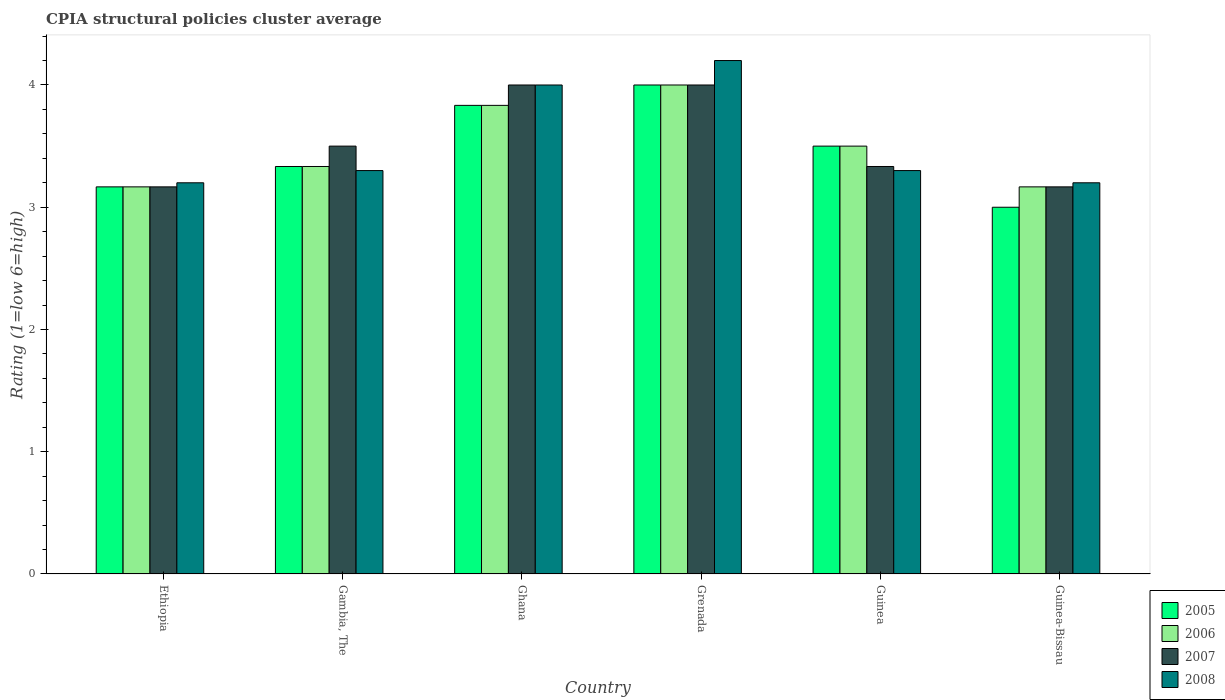How many different coloured bars are there?
Make the answer very short. 4. Are the number of bars per tick equal to the number of legend labels?
Your answer should be very brief. Yes. Are the number of bars on each tick of the X-axis equal?
Keep it short and to the point. Yes. How many bars are there on the 6th tick from the left?
Give a very brief answer. 4. How many bars are there on the 6th tick from the right?
Ensure brevity in your answer.  4. What is the label of the 6th group of bars from the left?
Provide a succinct answer. Guinea-Bissau. In how many cases, is the number of bars for a given country not equal to the number of legend labels?
Your answer should be very brief. 0. Across all countries, what is the maximum CPIA rating in 2005?
Keep it short and to the point. 4. In which country was the CPIA rating in 2008 maximum?
Keep it short and to the point. Grenada. In which country was the CPIA rating in 2007 minimum?
Your response must be concise. Ethiopia. What is the total CPIA rating in 2008 in the graph?
Your answer should be very brief. 21.2. What is the difference between the CPIA rating in 2005 in Grenada and that in Guinea-Bissau?
Provide a succinct answer. 1. What is the difference between the CPIA rating in 2007 in Ethiopia and the CPIA rating in 2005 in Grenada?
Ensure brevity in your answer.  -0.83. What is the average CPIA rating in 2008 per country?
Provide a short and direct response. 3.53. What is the difference between the CPIA rating of/in 2008 and CPIA rating of/in 2007 in Guinea-Bissau?
Ensure brevity in your answer.  0.03. In how many countries, is the CPIA rating in 2005 greater than 4?
Give a very brief answer. 0. What is the ratio of the CPIA rating in 2005 in Ethiopia to that in Guinea?
Provide a short and direct response. 0.9. Is the CPIA rating in 2008 in Ghana less than that in Guinea-Bissau?
Give a very brief answer. No. Is the difference between the CPIA rating in 2008 in Gambia, The and Ghana greater than the difference between the CPIA rating in 2007 in Gambia, The and Ghana?
Your answer should be compact. No. What is the difference between the highest and the second highest CPIA rating in 2005?
Provide a short and direct response. -0.33. What is the difference between the highest and the lowest CPIA rating in 2006?
Provide a succinct answer. 0.83. In how many countries, is the CPIA rating in 2007 greater than the average CPIA rating in 2007 taken over all countries?
Offer a terse response. 2. Is it the case that in every country, the sum of the CPIA rating in 2006 and CPIA rating in 2005 is greater than the sum of CPIA rating in 2008 and CPIA rating in 2007?
Give a very brief answer. No. What does the 3rd bar from the left in Guinea-Bissau represents?
Make the answer very short. 2007. What does the 3rd bar from the right in Ethiopia represents?
Offer a very short reply. 2006. How many bars are there?
Give a very brief answer. 24. What is the difference between two consecutive major ticks on the Y-axis?
Offer a terse response. 1. Are the values on the major ticks of Y-axis written in scientific E-notation?
Your answer should be very brief. No. How many legend labels are there?
Provide a short and direct response. 4. How are the legend labels stacked?
Provide a succinct answer. Vertical. What is the title of the graph?
Keep it short and to the point. CPIA structural policies cluster average. What is the label or title of the X-axis?
Ensure brevity in your answer.  Country. What is the Rating (1=low 6=high) in 2005 in Ethiopia?
Your response must be concise. 3.17. What is the Rating (1=low 6=high) in 2006 in Ethiopia?
Ensure brevity in your answer.  3.17. What is the Rating (1=low 6=high) of 2007 in Ethiopia?
Your answer should be very brief. 3.17. What is the Rating (1=low 6=high) in 2005 in Gambia, The?
Offer a terse response. 3.33. What is the Rating (1=low 6=high) in 2006 in Gambia, The?
Provide a succinct answer. 3.33. What is the Rating (1=low 6=high) of 2008 in Gambia, The?
Your response must be concise. 3.3. What is the Rating (1=low 6=high) of 2005 in Ghana?
Offer a very short reply. 3.83. What is the Rating (1=low 6=high) of 2006 in Ghana?
Ensure brevity in your answer.  3.83. What is the Rating (1=low 6=high) of 2007 in Ghana?
Offer a very short reply. 4. What is the Rating (1=low 6=high) in 2008 in Ghana?
Give a very brief answer. 4. What is the Rating (1=low 6=high) of 2005 in Grenada?
Provide a succinct answer. 4. What is the Rating (1=low 6=high) of 2006 in Grenada?
Keep it short and to the point. 4. What is the Rating (1=low 6=high) in 2007 in Grenada?
Ensure brevity in your answer.  4. What is the Rating (1=low 6=high) of 2007 in Guinea?
Keep it short and to the point. 3.33. What is the Rating (1=low 6=high) in 2008 in Guinea?
Provide a succinct answer. 3.3. What is the Rating (1=low 6=high) of 2006 in Guinea-Bissau?
Make the answer very short. 3.17. What is the Rating (1=low 6=high) of 2007 in Guinea-Bissau?
Keep it short and to the point. 3.17. Across all countries, what is the maximum Rating (1=low 6=high) of 2008?
Offer a terse response. 4.2. Across all countries, what is the minimum Rating (1=low 6=high) in 2005?
Your response must be concise. 3. Across all countries, what is the minimum Rating (1=low 6=high) of 2006?
Your answer should be compact. 3.17. Across all countries, what is the minimum Rating (1=low 6=high) in 2007?
Your answer should be compact. 3.17. What is the total Rating (1=low 6=high) in 2005 in the graph?
Your answer should be compact. 20.83. What is the total Rating (1=low 6=high) in 2007 in the graph?
Offer a very short reply. 21.17. What is the total Rating (1=low 6=high) in 2008 in the graph?
Ensure brevity in your answer.  21.2. What is the difference between the Rating (1=low 6=high) in 2005 in Ethiopia and that in Gambia, The?
Ensure brevity in your answer.  -0.17. What is the difference between the Rating (1=low 6=high) of 2006 in Ethiopia and that in Gambia, The?
Your answer should be compact. -0.17. What is the difference between the Rating (1=low 6=high) of 2008 in Ethiopia and that in Gambia, The?
Give a very brief answer. -0.1. What is the difference between the Rating (1=low 6=high) of 2005 in Ethiopia and that in Ghana?
Your answer should be very brief. -0.67. What is the difference between the Rating (1=low 6=high) of 2007 in Ethiopia and that in Ghana?
Make the answer very short. -0.83. What is the difference between the Rating (1=low 6=high) of 2005 in Ethiopia and that in Guinea-Bissau?
Your response must be concise. 0.17. What is the difference between the Rating (1=low 6=high) in 2008 in Ethiopia and that in Guinea-Bissau?
Offer a very short reply. 0. What is the difference between the Rating (1=low 6=high) in 2006 in Gambia, The and that in Ghana?
Your response must be concise. -0.5. What is the difference between the Rating (1=low 6=high) of 2008 in Gambia, The and that in Ghana?
Give a very brief answer. -0.7. What is the difference between the Rating (1=low 6=high) of 2005 in Gambia, The and that in Grenada?
Offer a terse response. -0.67. What is the difference between the Rating (1=low 6=high) in 2007 in Gambia, The and that in Grenada?
Provide a succinct answer. -0.5. What is the difference between the Rating (1=low 6=high) of 2005 in Gambia, The and that in Guinea?
Your answer should be compact. -0.17. What is the difference between the Rating (1=low 6=high) in 2007 in Gambia, The and that in Guinea?
Keep it short and to the point. 0.17. What is the difference between the Rating (1=low 6=high) in 2005 in Gambia, The and that in Guinea-Bissau?
Your answer should be very brief. 0.33. What is the difference between the Rating (1=low 6=high) in 2006 in Gambia, The and that in Guinea-Bissau?
Your answer should be compact. 0.17. What is the difference between the Rating (1=low 6=high) in 2008 in Gambia, The and that in Guinea-Bissau?
Offer a very short reply. 0.1. What is the difference between the Rating (1=low 6=high) in 2005 in Ghana and that in Grenada?
Provide a short and direct response. -0.17. What is the difference between the Rating (1=low 6=high) of 2008 in Ghana and that in Grenada?
Your answer should be compact. -0.2. What is the difference between the Rating (1=low 6=high) of 2007 in Ghana and that in Guinea?
Provide a short and direct response. 0.67. What is the difference between the Rating (1=low 6=high) of 2008 in Ghana and that in Guinea?
Offer a very short reply. 0.7. What is the difference between the Rating (1=low 6=high) in 2006 in Ghana and that in Guinea-Bissau?
Keep it short and to the point. 0.67. What is the difference between the Rating (1=low 6=high) in 2005 in Grenada and that in Guinea?
Provide a succinct answer. 0.5. What is the difference between the Rating (1=low 6=high) of 2007 in Grenada and that in Guinea?
Ensure brevity in your answer.  0.67. What is the difference between the Rating (1=low 6=high) of 2008 in Grenada and that in Guinea?
Give a very brief answer. 0.9. What is the difference between the Rating (1=low 6=high) in 2005 in Grenada and that in Guinea-Bissau?
Make the answer very short. 1. What is the difference between the Rating (1=low 6=high) in 2007 in Grenada and that in Guinea-Bissau?
Give a very brief answer. 0.83. What is the difference between the Rating (1=low 6=high) in 2008 in Grenada and that in Guinea-Bissau?
Offer a terse response. 1. What is the difference between the Rating (1=low 6=high) in 2006 in Guinea and that in Guinea-Bissau?
Offer a very short reply. 0.33. What is the difference between the Rating (1=low 6=high) of 2007 in Guinea and that in Guinea-Bissau?
Ensure brevity in your answer.  0.17. What is the difference between the Rating (1=low 6=high) of 2008 in Guinea and that in Guinea-Bissau?
Give a very brief answer. 0.1. What is the difference between the Rating (1=low 6=high) of 2005 in Ethiopia and the Rating (1=low 6=high) of 2006 in Gambia, The?
Provide a short and direct response. -0.17. What is the difference between the Rating (1=low 6=high) of 2005 in Ethiopia and the Rating (1=low 6=high) of 2007 in Gambia, The?
Offer a terse response. -0.33. What is the difference between the Rating (1=low 6=high) of 2005 in Ethiopia and the Rating (1=low 6=high) of 2008 in Gambia, The?
Your answer should be very brief. -0.13. What is the difference between the Rating (1=low 6=high) of 2006 in Ethiopia and the Rating (1=low 6=high) of 2008 in Gambia, The?
Ensure brevity in your answer.  -0.13. What is the difference between the Rating (1=low 6=high) in 2007 in Ethiopia and the Rating (1=low 6=high) in 2008 in Gambia, The?
Keep it short and to the point. -0.13. What is the difference between the Rating (1=low 6=high) of 2005 in Ethiopia and the Rating (1=low 6=high) of 2007 in Ghana?
Provide a short and direct response. -0.83. What is the difference between the Rating (1=low 6=high) in 2006 in Ethiopia and the Rating (1=low 6=high) in 2008 in Ghana?
Offer a very short reply. -0.83. What is the difference between the Rating (1=low 6=high) in 2007 in Ethiopia and the Rating (1=low 6=high) in 2008 in Ghana?
Offer a very short reply. -0.83. What is the difference between the Rating (1=low 6=high) in 2005 in Ethiopia and the Rating (1=low 6=high) in 2008 in Grenada?
Offer a terse response. -1.03. What is the difference between the Rating (1=low 6=high) in 2006 in Ethiopia and the Rating (1=low 6=high) in 2007 in Grenada?
Your answer should be compact. -0.83. What is the difference between the Rating (1=low 6=high) of 2006 in Ethiopia and the Rating (1=low 6=high) of 2008 in Grenada?
Offer a very short reply. -1.03. What is the difference between the Rating (1=low 6=high) of 2007 in Ethiopia and the Rating (1=low 6=high) of 2008 in Grenada?
Your answer should be compact. -1.03. What is the difference between the Rating (1=low 6=high) of 2005 in Ethiopia and the Rating (1=low 6=high) of 2006 in Guinea?
Ensure brevity in your answer.  -0.33. What is the difference between the Rating (1=low 6=high) in 2005 in Ethiopia and the Rating (1=low 6=high) in 2008 in Guinea?
Give a very brief answer. -0.13. What is the difference between the Rating (1=low 6=high) in 2006 in Ethiopia and the Rating (1=low 6=high) in 2008 in Guinea?
Ensure brevity in your answer.  -0.13. What is the difference between the Rating (1=low 6=high) of 2007 in Ethiopia and the Rating (1=low 6=high) of 2008 in Guinea?
Your answer should be compact. -0.13. What is the difference between the Rating (1=low 6=high) in 2005 in Ethiopia and the Rating (1=low 6=high) in 2008 in Guinea-Bissau?
Offer a very short reply. -0.03. What is the difference between the Rating (1=low 6=high) in 2006 in Ethiopia and the Rating (1=low 6=high) in 2008 in Guinea-Bissau?
Give a very brief answer. -0.03. What is the difference between the Rating (1=low 6=high) in 2007 in Ethiopia and the Rating (1=low 6=high) in 2008 in Guinea-Bissau?
Keep it short and to the point. -0.03. What is the difference between the Rating (1=low 6=high) in 2005 in Gambia, The and the Rating (1=low 6=high) in 2006 in Ghana?
Your answer should be compact. -0.5. What is the difference between the Rating (1=low 6=high) in 2005 in Gambia, The and the Rating (1=low 6=high) in 2008 in Ghana?
Provide a short and direct response. -0.67. What is the difference between the Rating (1=low 6=high) of 2005 in Gambia, The and the Rating (1=low 6=high) of 2008 in Grenada?
Provide a short and direct response. -0.87. What is the difference between the Rating (1=low 6=high) of 2006 in Gambia, The and the Rating (1=low 6=high) of 2008 in Grenada?
Ensure brevity in your answer.  -0.87. What is the difference between the Rating (1=low 6=high) of 2005 in Gambia, The and the Rating (1=low 6=high) of 2006 in Guinea?
Offer a very short reply. -0.17. What is the difference between the Rating (1=low 6=high) in 2006 in Gambia, The and the Rating (1=low 6=high) in 2007 in Guinea?
Your answer should be very brief. 0. What is the difference between the Rating (1=low 6=high) of 2005 in Gambia, The and the Rating (1=low 6=high) of 2006 in Guinea-Bissau?
Provide a succinct answer. 0.17. What is the difference between the Rating (1=low 6=high) in 2005 in Gambia, The and the Rating (1=low 6=high) in 2007 in Guinea-Bissau?
Offer a very short reply. 0.17. What is the difference between the Rating (1=low 6=high) in 2005 in Gambia, The and the Rating (1=low 6=high) in 2008 in Guinea-Bissau?
Offer a terse response. 0.13. What is the difference between the Rating (1=low 6=high) in 2006 in Gambia, The and the Rating (1=low 6=high) in 2007 in Guinea-Bissau?
Provide a succinct answer. 0.17. What is the difference between the Rating (1=low 6=high) in 2006 in Gambia, The and the Rating (1=low 6=high) in 2008 in Guinea-Bissau?
Provide a succinct answer. 0.13. What is the difference between the Rating (1=low 6=high) in 2005 in Ghana and the Rating (1=low 6=high) in 2008 in Grenada?
Your answer should be very brief. -0.37. What is the difference between the Rating (1=low 6=high) of 2006 in Ghana and the Rating (1=low 6=high) of 2008 in Grenada?
Your answer should be very brief. -0.37. What is the difference between the Rating (1=low 6=high) of 2005 in Ghana and the Rating (1=low 6=high) of 2007 in Guinea?
Your answer should be compact. 0.5. What is the difference between the Rating (1=low 6=high) of 2005 in Ghana and the Rating (1=low 6=high) of 2008 in Guinea?
Keep it short and to the point. 0.53. What is the difference between the Rating (1=low 6=high) of 2006 in Ghana and the Rating (1=low 6=high) of 2007 in Guinea?
Offer a terse response. 0.5. What is the difference between the Rating (1=low 6=high) of 2006 in Ghana and the Rating (1=low 6=high) of 2008 in Guinea?
Your answer should be very brief. 0.53. What is the difference between the Rating (1=low 6=high) of 2005 in Ghana and the Rating (1=low 6=high) of 2006 in Guinea-Bissau?
Your answer should be compact. 0.67. What is the difference between the Rating (1=low 6=high) in 2005 in Ghana and the Rating (1=low 6=high) in 2007 in Guinea-Bissau?
Provide a succinct answer. 0.67. What is the difference between the Rating (1=low 6=high) of 2005 in Ghana and the Rating (1=low 6=high) of 2008 in Guinea-Bissau?
Give a very brief answer. 0.63. What is the difference between the Rating (1=low 6=high) of 2006 in Ghana and the Rating (1=low 6=high) of 2007 in Guinea-Bissau?
Make the answer very short. 0.67. What is the difference between the Rating (1=low 6=high) in 2006 in Ghana and the Rating (1=low 6=high) in 2008 in Guinea-Bissau?
Your answer should be compact. 0.63. What is the difference between the Rating (1=low 6=high) in 2007 in Ghana and the Rating (1=low 6=high) in 2008 in Guinea-Bissau?
Ensure brevity in your answer.  0.8. What is the difference between the Rating (1=low 6=high) in 2005 in Grenada and the Rating (1=low 6=high) in 2006 in Guinea?
Give a very brief answer. 0.5. What is the difference between the Rating (1=low 6=high) in 2005 in Grenada and the Rating (1=low 6=high) in 2007 in Guinea?
Offer a terse response. 0.67. What is the difference between the Rating (1=low 6=high) in 2005 in Grenada and the Rating (1=low 6=high) in 2007 in Guinea-Bissau?
Keep it short and to the point. 0.83. What is the difference between the Rating (1=low 6=high) of 2006 in Grenada and the Rating (1=low 6=high) of 2008 in Guinea-Bissau?
Offer a terse response. 0.8. What is the difference between the Rating (1=low 6=high) of 2005 in Guinea and the Rating (1=low 6=high) of 2006 in Guinea-Bissau?
Your answer should be very brief. 0.33. What is the difference between the Rating (1=low 6=high) of 2005 in Guinea and the Rating (1=low 6=high) of 2007 in Guinea-Bissau?
Your answer should be very brief. 0.33. What is the difference between the Rating (1=low 6=high) in 2006 in Guinea and the Rating (1=low 6=high) in 2007 in Guinea-Bissau?
Your answer should be compact. 0.33. What is the difference between the Rating (1=low 6=high) in 2006 in Guinea and the Rating (1=low 6=high) in 2008 in Guinea-Bissau?
Keep it short and to the point. 0.3. What is the difference between the Rating (1=low 6=high) in 2007 in Guinea and the Rating (1=low 6=high) in 2008 in Guinea-Bissau?
Offer a terse response. 0.13. What is the average Rating (1=low 6=high) of 2005 per country?
Make the answer very short. 3.47. What is the average Rating (1=low 6=high) in 2007 per country?
Your response must be concise. 3.53. What is the average Rating (1=low 6=high) of 2008 per country?
Offer a terse response. 3.53. What is the difference between the Rating (1=low 6=high) in 2005 and Rating (1=low 6=high) in 2006 in Ethiopia?
Offer a terse response. 0. What is the difference between the Rating (1=low 6=high) in 2005 and Rating (1=low 6=high) in 2008 in Ethiopia?
Ensure brevity in your answer.  -0.03. What is the difference between the Rating (1=low 6=high) of 2006 and Rating (1=low 6=high) of 2008 in Ethiopia?
Keep it short and to the point. -0.03. What is the difference between the Rating (1=low 6=high) in 2007 and Rating (1=low 6=high) in 2008 in Ethiopia?
Keep it short and to the point. -0.03. What is the difference between the Rating (1=low 6=high) of 2005 and Rating (1=low 6=high) of 2006 in Gambia, The?
Offer a very short reply. 0. What is the difference between the Rating (1=low 6=high) in 2005 and Rating (1=low 6=high) in 2007 in Gambia, The?
Offer a very short reply. -0.17. What is the difference between the Rating (1=low 6=high) of 2006 and Rating (1=low 6=high) of 2008 in Gambia, The?
Provide a short and direct response. 0.03. What is the difference between the Rating (1=low 6=high) of 2007 and Rating (1=low 6=high) of 2008 in Gambia, The?
Keep it short and to the point. 0.2. What is the difference between the Rating (1=low 6=high) of 2005 and Rating (1=low 6=high) of 2006 in Ghana?
Provide a succinct answer. 0. What is the difference between the Rating (1=low 6=high) of 2005 and Rating (1=low 6=high) of 2007 in Ghana?
Your answer should be compact. -0.17. What is the difference between the Rating (1=low 6=high) in 2006 and Rating (1=low 6=high) in 2008 in Ghana?
Your response must be concise. -0.17. What is the difference between the Rating (1=low 6=high) of 2005 and Rating (1=low 6=high) of 2007 in Grenada?
Your answer should be very brief. 0. What is the difference between the Rating (1=low 6=high) of 2005 and Rating (1=low 6=high) of 2008 in Grenada?
Offer a terse response. -0.2. What is the difference between the Rating (1=low 6=high) in 2006 and Rating (1=low 6=high) in 2007 in Grenada?
Your answer should be very brief. 0. What is the difference between the Rating (1=low 6=high) in 2007 and Rating (1=low 6=high) in 2008 in Grenada?
Offer a very short reply. -0.2. What is the difference between the Rating (1=low 6=high) of 2005 and Rating (1=low 6=high) of 2006 in Guinea?
Your answer should be very brief. 0. What is the difference between the Rating (1=low 6=high) in 2006 and Rating (1=low 6=high) in 2007 in Guinea?
Provide a succinct answer. 0.17. What is the difference between the Rating (1=low 6=high) of 2006 and Rating (1=low 6=high) of 2008 in Guinea?
Offer a terse response. 0.2. What is the difference between the Rating (1=low 6=high) in 2005 and Rating (1=low 6=high) in 2007 in Guinea-Bissau?
Your answer should be very brief. -0.17. What is the difference between the Rating (1=low 6=high) of 2006 and Rating (1=low 6=high) of 2008 in Guinea-Bissau?
Give a very brief answer. -0.03. What is the difference between the Rating (1=low 6=high) of 2007 and Rating (1=low 6=high) of 2008 in Guinea-Bissau?
Your answer should be compact. -0.03. What is the ratio of the Rating (1=low 6=high) of 2005 in Ethiopia to that in Gambia, The?
Offer a terse response. 0.95. What is the ratio of the Rating (1=low 6=high) of 2007 in Ethiopia to that in Gambia, The?
Your answer should be compact. 0.9. What is the ratio of the Rating (1=low 6=high) in 2008 in Ethiopia to that in Gambia, The?
Provide a succinct answer. 0.97. What is the ratio of the Rating (1=low 6=high) of 2005 in Ethiopia to that in Ghana?
Give a very brief answer. 0.83. What is the ratio of the Rating (1=low 6=high) of 2006 in Ethiopia to that in Ghana?
Your response must be concise. 0.83. What is the ratio of the Rating (1=low 6=high) of 2007 in Ethiopia to that in Ghana?
Make the answer very short. 0.79. What is the ratio of the Rating (1=low 6=high) in 2008 in Ethiopia to that in Ghana?
Keep it short and to the point. 0.8. What is the ratio of the Rating (1=low 6=high) of 2005 in Ethiopia to that in Grenada?
Offer a terse response. 0.79. What is the ratio of the Rating (1=low 6=high) in 2006 in Ethiopia to that in Grenada?
Provide a succinct answer. 0.79. What is the ratio of the Rating (1=low 6=high) of 2007 in Ethiopia to that in Grenada?
Your response must be concise. 0.79. What is the ratio of the Rating (1=low 6=high) of 2008 in Ethiopia to that in Grenada?
Keep it short and to the point. 0.76. What is the ratio of the Rating (1=low 6=high) of 2005 in Ethiopia to that in Guinea?
Your answer should be compact. 0.9. What is the ratio of the Rating (1=low 6=high) in 2006 in Ethiopia to that in Guinea?
Offer a terse response. 0.9. What is the ratio of the Rating (1=low 6=high) in 2008 in Ethiopia to that in Guinea?
Provide a succinct answer. 0.97. What is the ratio of the Rating (1=low 6=high) of 2005 in Ethiopia to that in Guinea-Bissau?
Offer a very short reply. 1.06. What is the ratio of the Rating (1=low 6=high) of 2008 in Ethiopia to that in Guinea-Bissau?
Ensure brevity in your answer.  1. What is the ratio of the Rating (1=low 6=high) in 2005 in Gambia, The to that in Ghana?
Provide a short and direct response. 0.87. What is the ratio of the Rating (1=low 6=high) of 2006 in Gambia, The to that in Ghana?
Offer a very short reply. 0.87. What is the ratio of the Rating (1=low 6=high) of 2007 in Gambia, The to that in Ghana?
Your answer should be compact. 0.88. What is the ratio of the Rating (1=low 6=high) of 2008 in Gambia, The to that in Ghana?
Give a very brief answer. 0.82. What is the ratio of the Rating (1=low 6=high) of 2006 in Gambia, The to that in Grenada?
Give a very brief answer. 0.83. What is the ratio of the Rating (1=low 6=high) of 2007 in Gambia, The to that in Grenada?
Give a very brief answer. 0.88. What is the ratio of the Rating (1=low 6=high) of 2008 in Gambia, The to that in Grenada?
Keep it short and to the point. 0.79. What is the ratio of the Rating (1=low 6=high) in 2006 in Gambia, The to that in Guinea?
Provide a succinct answer. 0.95. What is the ratio of the Rating (1=low 6=high) in 2007 in Gambia, The to that in Guinea?
Give a very brief answer. 1.05. What is the ratio of the Rating (1=low 6=high) of 2008 in Gambia, The to that in Guinea?
Your answer should be very brief. 1. What is the ratio of the Rating (1=low 6=high) of 2005 in Gambia, The to that in Guinea-Bissau?
Your answer should be very brief. 1.11. What is the ratio of the Rating (1=low 6=high) in 2006 in Gambia, The to that in Guinea-Bissau?
Your answer should be very brief. 1.05. What is the ratio of the Rating (1=low 6=high) in 2007 in Gambia, The to that in Guinea-Bissau?
Your answer should be compact. 1.11. What is the ratio of the Rating (1=low 6=high) in 2008 in Gambia, The to that in Guinea-Bissau?
Provide a short and direct response. 1.03. What is the ratio of the Rating (1=low 6=high) in 2005 in Ghana to that in Grenada?
Make the answer very short. 0.96. What is the ratio of the Rating (1=low 6=high) in 2007 in Ghana to that in Grenada?
Make the answer very short. 1. What is the ratio of the Rating (1=low 6=high) of 2008 in Ghana to that in Grenada?
Give a very brief answer. 0.95. What is the ratio of the Rating (1=low 6=high) in 2005 in Ghana to that in Guinea?
Keep it short and to the point. 1.1. What is the ratio of the Rating (1=low 6=high) of 2006 in Ghana to that in Guinea?
Provide a succinct answer. 1.1. What is the ratio of the Rating (1=low 6=high) of 2007 in Ghana to that in Guinea?
Your answer should be compact. 1.2. What is the ratio of the Rating (1=low 6=high) in 2008 in Ghana to that in Guinea?
Provide a succinct answer. 1.21. What is the ratio of the Rating (1=low 6=high) of 2005 in Ghana to that in Guinea-Bissau?
Provide a short and direct response. 1.28. What is the ratio of the Rating (1=low 6=high) of 2006 in Ghana to that in Guinea-Bissau?
Your response must be concise. 1.21. What is the ratio of the Rating (1=low 6=high) of 2007 in Ghana to that in Guinea-Bissau?
Provide a succinct answer. 1.26. What is the ratio of the Rating (1=low 6=high) in 2005 in Grenada to that in Guinea?
Provide a short and direct response. 1.14. What is the ratio of the Rating (1=low 6=high) of 2007 in Grenada to that in Guinea?
Offer a very short reply. 1.2. What is the ratio of the Rating (1=low 6=high) of 2008 in Grenada to that in Guinea?
Offer a terse response. 1.27. What is the ratio of the Rating (1=low 6=high) in 2006 in Grenada to that in Guinea-Bissau?
Keep it short and to the point. 1.26. What is the ratio of the Rating (1=low 6=high) of 2007 in Grenada to that in Guinea-Bissau?
Give a very brief answer. 1.26. What is the ratio of the Rating (1=low 6=high) of 2008 in Grenada to that in Guinea-Bissau?
Provide a succinct answer. 1.31. What is the ratio of the Rating (1=low 6=high) in 2005 in Guinea to that in Guinea-Bissau?
Your response must be concise. 1.17. What is the ratio of the Rating (1=low 6=high) of 2006 in Guinea to that in Guinea-Bissau?
Offer a terse response. 1.11. What is the ratio of the Rating (1=low 6=high) of 2007 in Guinea to that in Guinea-Bissau?
Provide a succinct answer. 1.05. What is the ratio of the Rating (1=low 6=high) in 2008 in Guinea to that in Guinea-Bissau?
Your answer should be very brief. 1.03. What is the difference between the highest and the second highest Rating (1=low 6=high) in 2006?
Make the answer very short. 0.17. What is the difference between the highest and the second highest Rating (1=low 6=high) of 2008?
Offer a very short reply. 0.2. What is the difference between the highest and the lowest Rating (1=low 6=high) of 2006?
Provide a succinct answer. 0.83. What is the difference between the highest and the lowest Rating (1=low 6=high) of 2007?
Ensure brevity in your answer.  0.83. 